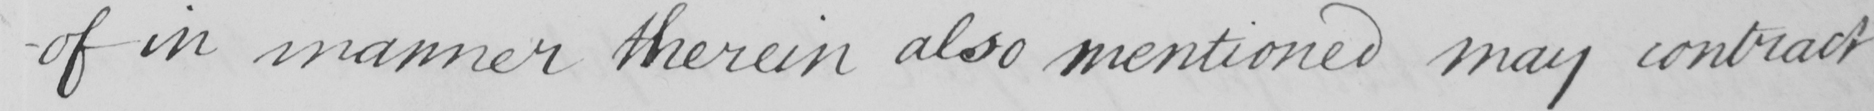Please transcribe the handwritten text in this image. -of in manner therein also mentioned may contract 